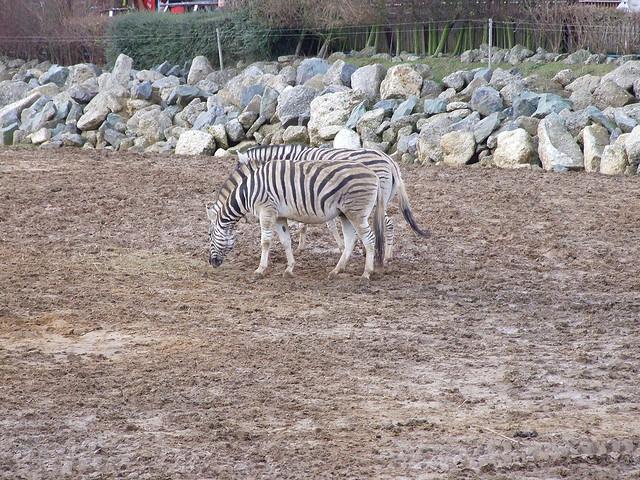Where are the rocks?
Give a very brief answer. Behind zebras. Do these animals need a bath?
Concise answer only. Yes. Are the zebras the same size?
Quick response, please. No. 